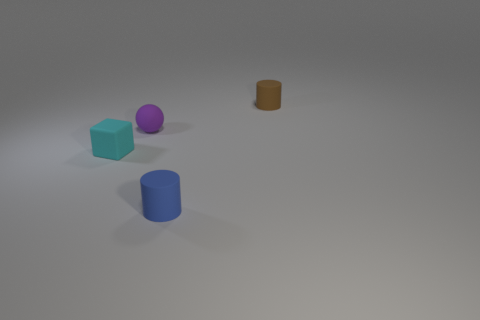How many spheres are either blue matte things or tiny matte objects?
Keep it short and to the point. 1. There is a tiny rubber cylinder that is behind the block; are there any brown rubber objects behind it?
Give a very brief answer. No. Is the shape of the blue thing the same as the small object on the right side of the blue rubber object?
Your response must be concise. Yes. What number of other things are the same size as the rubber sphere?
Offer a very short reply. 3. What number of cyan objects are cylinders or tiny rubber cubes?
Your answer should be compact. 1. What number of matte things are to the right of the small purple sphere and in front of the purple thing?
Ensure brevity in your answer.  1. There is a cylinder left of the rubber cylinder behind the tiny cyan object behind the blue matte object; what is its material?
Offer a very short reply. Rubber. What number of blue cylinders are the same material as the block?
Your response must be concise. 1. There is a blue matte object that is the same size as the brown object; what is its shape?
Your answer should be very brief. Cylinder. Are there any small matte cubes on the left side of the small purple sphere?
Provide a succinct answer. Yes. 